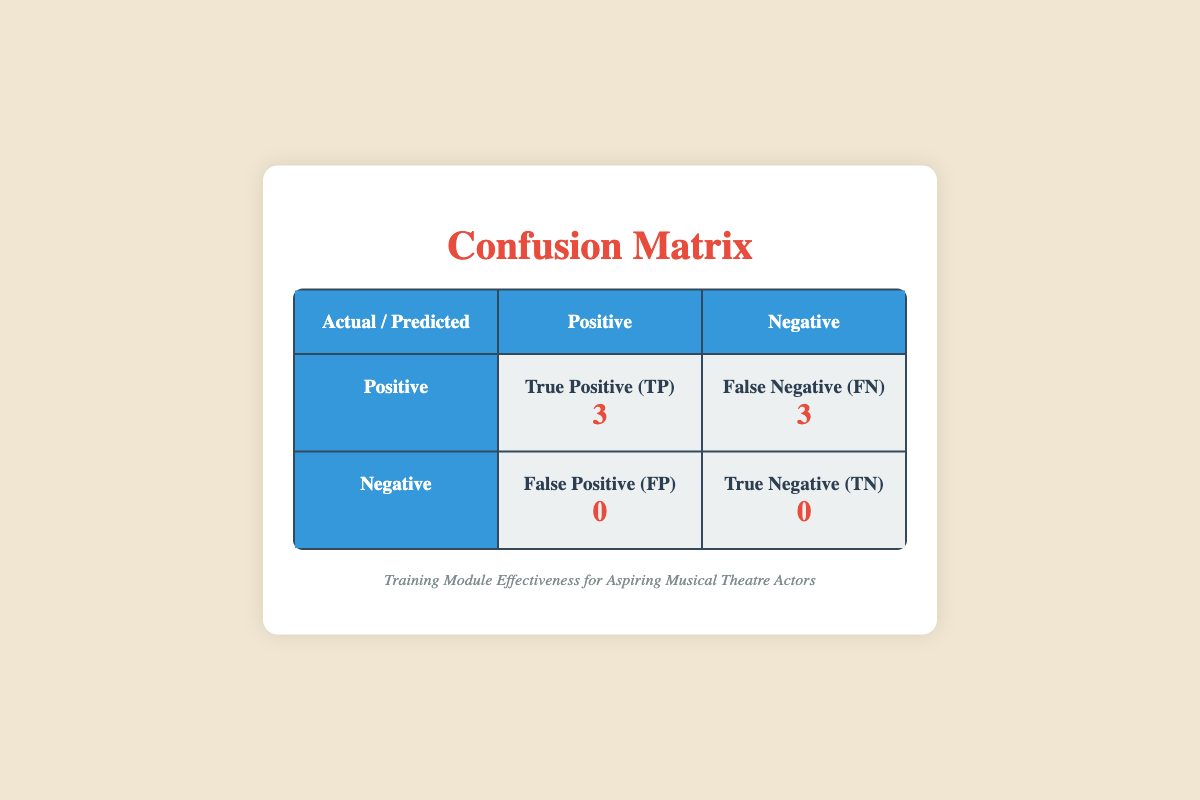What is the number of True Positives in the confusion matrix? The table shows that the True Positive (TP) value is listed under the positive column for predicted outcomes, which is specifically mentioned as 3.
Answer: 3 How many participants were unsuccessful across all training modules? By looking at the list of participants in each module, Emily, Liam, Sophie, Jackson, Chloe, and Ethan are noted. The unsuccessful participants are Liam, Jackson, and Ethan, totaling 3 participants.
Answer: 3 Is the number of True Negatives greater than the number of False Positives? The table indicates that True Negatives (TN) is 0 and False Positives (FP) is also 0. Since both values are equal, the statement is false.
Answer: No What is the overall number of successful participants across all training modules? From the participant data, Emily, Sophie, and Chloe are successful (indicated as true), with a total of 3 successful participants.
Answer: 3 What is the difference between the number of True Positives and False Negatives? The table states there are 3 True Positives (TP) and 3 False Negatives (FN). The difference is calculated as 3 - 3 = 0.
Answer: 0 How many total participants were assessed in the training modules? There are two participants per module for Vocal Techniques, Acting Basics, and Dance Fundamentals, resulting in a total of 6 participants (2 * 3 = 6).
Answer: 6 If we consider the total scores of successful participants, what is their sum? The successful participants' scores are 85 (Emily) + 90 (Sophie) + 80 (Chloe) = 255. The sum represents the total scores of all successful participants.
Answer: 255 What percentage of the total assessments were classified as successful? There are 3 successful participants out of a total of 6. The percentage is calculated as (3/6) * 100 = 50%, indicating half were successful.
Answer: 50% 